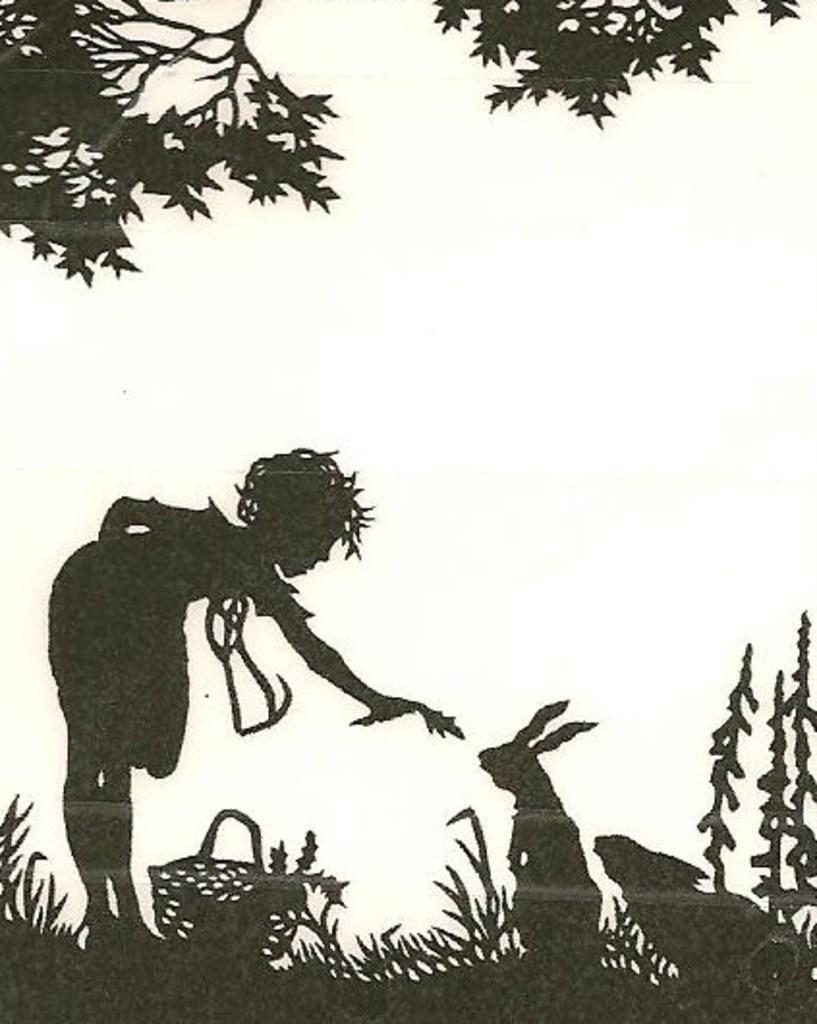How would you summarize this image in a sentence or two? This is a painting in this image there is one person and some rabbit, baskets and plants and trees. 